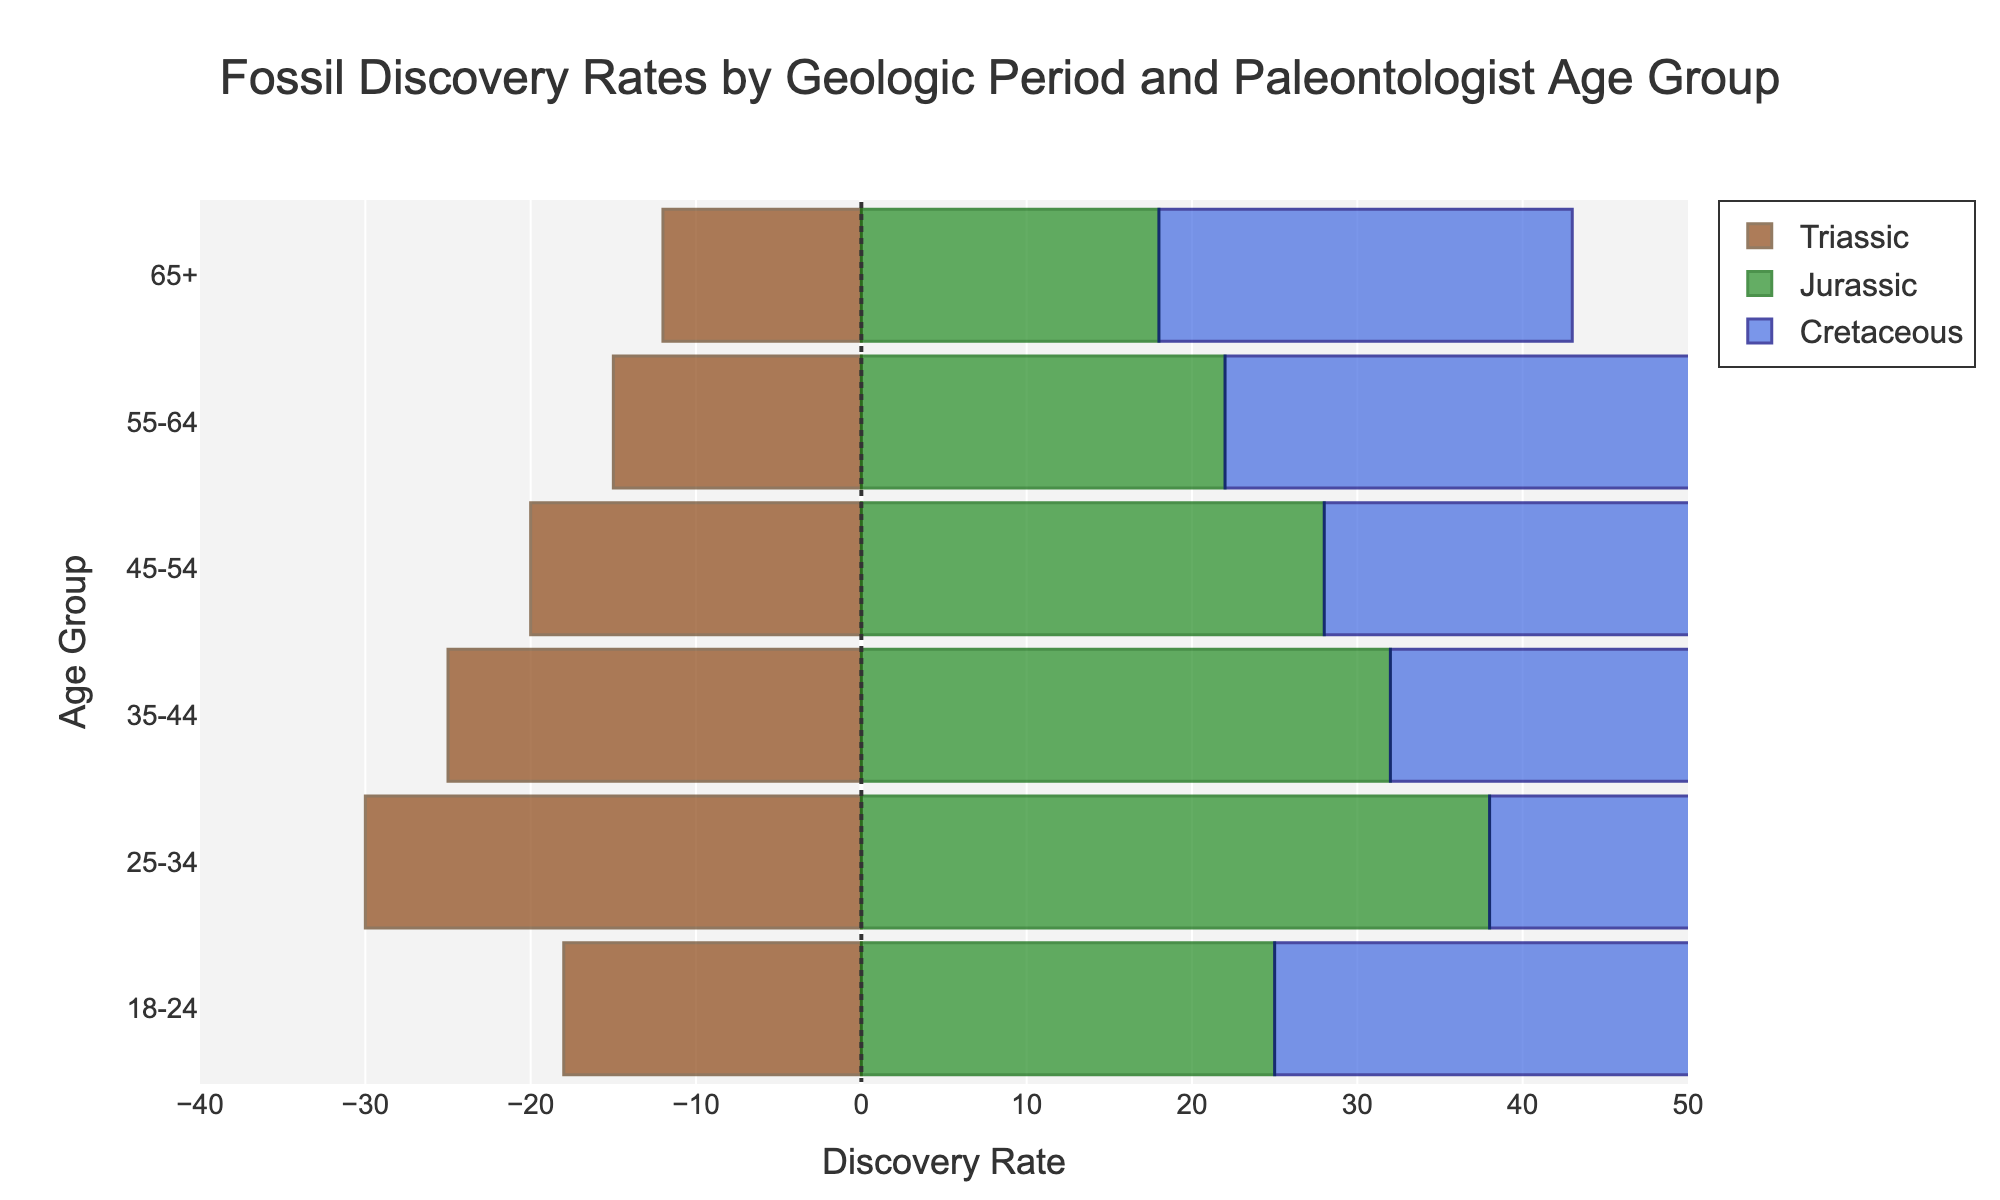What is the title of the plot? The title is usually located at the top of the figure and displays the main topic being visualized. In this case, it is "Fossil Discovery Rates by Geologic Period and Paleontologist Age Group."
Answer: Fossil Discovery Rates by Geologic Period and Paleontologist Age Group Which age group has the highest discovery rate for Cretaceous fossils? Locate the Cretaceous bar section, marked in blue, and identify the highest bar. The 25-34 age group has the highest discovery rate for Cretaceous fossils with a value of 45.
Answer: 25-34 What is the discovery rate for Jurassic fossils among the 45-54 age group? Look at the green bars representing Jurassic fossils and find the bar aligned with the 45-54 age group. The discovery rate is 28.
Answer: 28 How does the discovery rate of Triassic fossils for the 65+ age group compare to the 18-24 age group? Compare the length of the brown bars (indicating Triassic fossils) for the 65+ age group (-12) and the 18-24 age group (-18). The 18-24 age group has a lower (more negative) discovery rate than the 65+ age group.
Answer: 18-24 is lower What is the total discovery rate for the 55-64 age group across all periods? Sum the discovery rates for Triassic (-15), Jurassic (22), and Cretaceous (30) for the 55-64 age group. -15 + 22 + 30 = 37.
Answer: 37 Which age group shows a reversal in trend for Triassic fossil discovery compared to the other age groups? Notice all age groups have negative values for Triassic fossil discovery rates, but the degree of negativity decreases with increasing age groups. The trend does not reverse as all are negative, but less negative with older age groups.
Answer: None How does the discovery rate of Cretaceous fossils for the 35-44 age group compare to that of Jurassic fossils for the same age group? Compare the values for 35-44 in the blue (Cretaceous, 40) and green (Jurassic, 32) sections. The discovery rate for Cretaceous fossils is higher.
Answer: Cretaceous is higher What is the difference in discovery rates for Triassic fossils between the youngest and oldest age groups? Subtract the Triassic discovery rate for the 65+ group (-12) from that of the 18-24 group (-18). -18 - (-12) = -6.
Answer: -6 Which paleontologist age group has the most balanced discovery rates across the three periods? Identify the age group with similar bar lengths across all periods. The 45-54 age group has somewhat uniform rates for Triassic (-20), Jurassic (28), and Cretaceous (35).
Answer: 45-54 